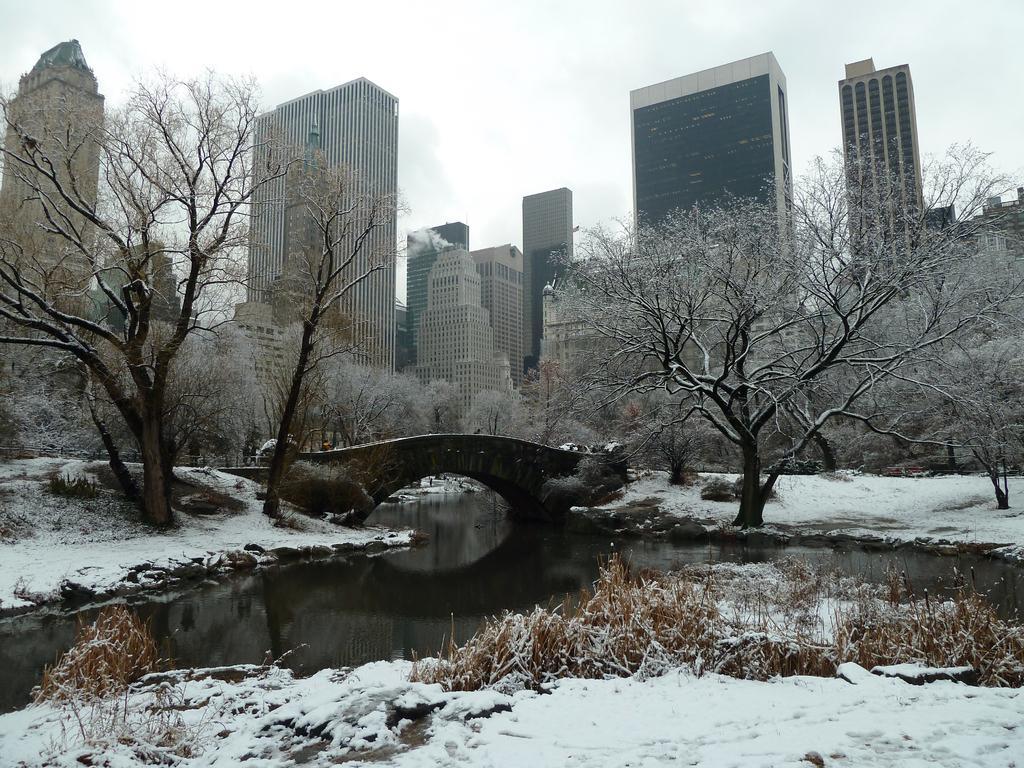Describe this image in one or two sentences. In this picture I can see snow. I can see water, bridge. There are buildings, trees, and in the background there is the sky. 